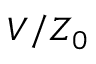<formula> <loc_0><loc_0><loc_500><loc_500>V / Z _ { 0 }</formula> 